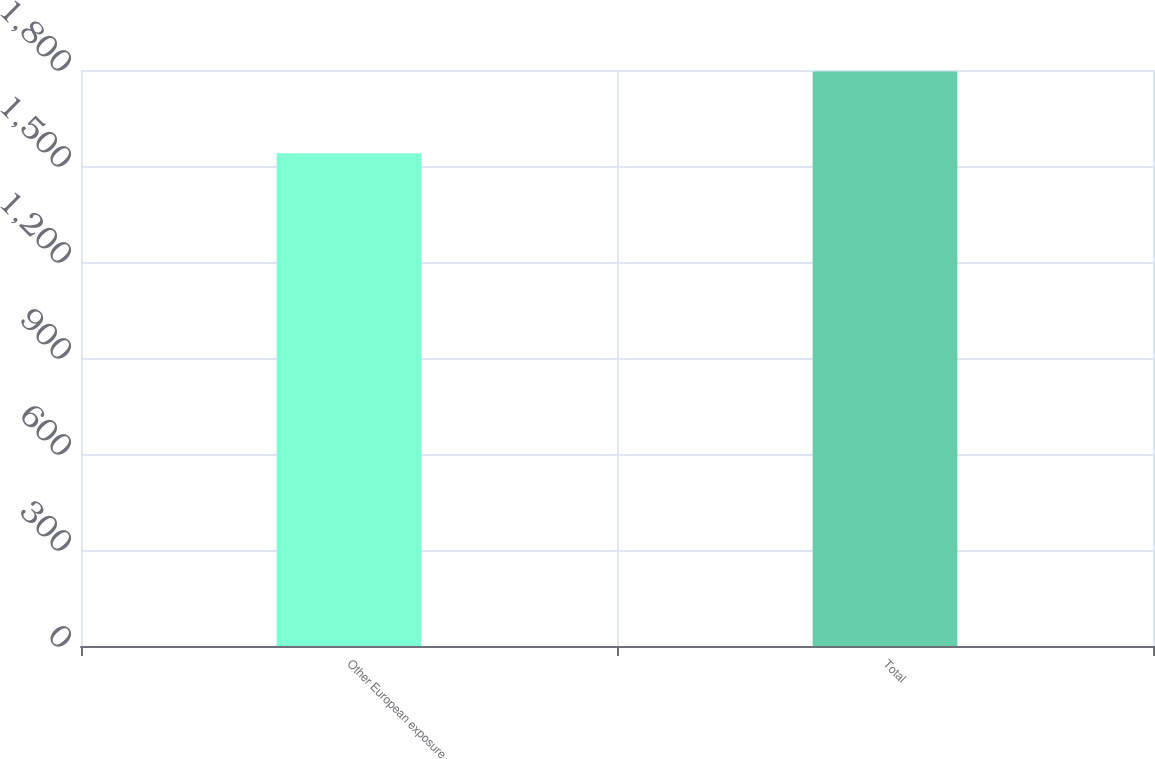Convert chart. <chart><loc_0><loc_0><loc_500><loc_500><bar_chart><fcel>Other European exposure<fcel>Total<nl><fcel>1540<fcel>1795<nl></chart> 